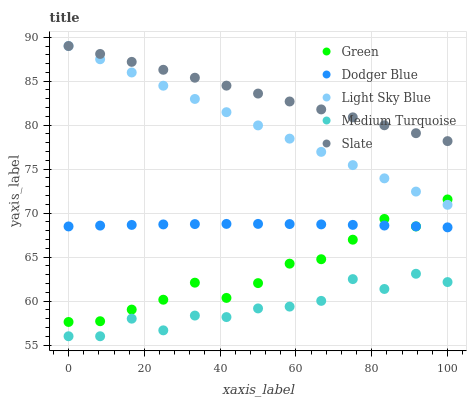Does Medium Turquoise have the minimum area under the curve?
Answer yes or no. Yes. Does Slate have the maximum area under the curve?
Answer yes or no. Yes. Does Light Sky Blue have the minimum area under the curve?
Answer yes or no. No. Does Light Sky Blue have the maximum area under the curve?
Answer yes or no. No. Is Light Sky Blue the smoothest?
Answer yes or no. Yes. Is Medium Turquoise the roughest?
Answer yes or no. Yes. Is Slate the smoothest?
Answer yes or no. No. Is Slate the roughest?
Answer yes or no. No. Does Medium Turquoise have the lowest value?
Answer yes or no. Yes. Does Light Sky Blue have the lowest value?
Answer yes or no. No. Does Light Sky Blue have the highest value?
Answer yes or no. Yes. Does Green have the highest value?
Answer yes or no. No. Is Medium Turquoise less than Slate?
Answer yes or no. Yes. Is Light Sky Blue greater than Medium Turquoise?
Answer yes or no. Yes. Does Green intersect Light Sky Blue?
Answer yes or no. Yes. Is Green less than Light Sky Blue?
Answer yes or no. No. Is Green greater than Light Sky Blue?
Answer yes or no. No. Does Medium Turquoise intersect Slate?
Answer yes or no. No. 